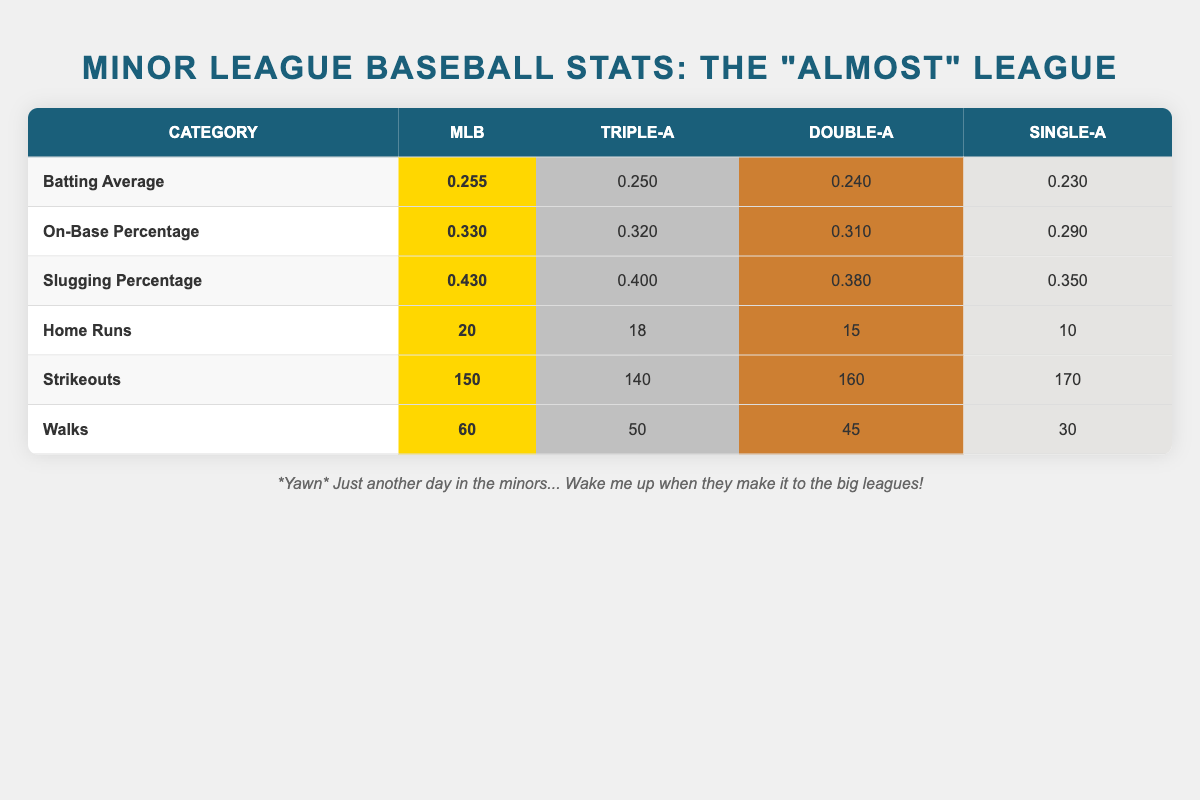What is the batting average for Triple-A players? In the table, under the "Batting Average" row for Triple-A, the value is listed as 0.250.
Answer: 0.250 How many home runs do Double-A players average? The table shows under the "Home Runs" row for Double-A that they average 15 home runs.
Answer: 15 Do Single-A players have a higher slugging percentage than Triple-A players? Looking at the "Slugging Percentage" row, Single-A has 0.350 while Triple-A has 0.400. Since 0.350 is less than 0.400, the answer is no.
Answer: No What is the difference in on-base percentage between MLB and Single-A players? The MLB on-base percentage is 0.330, while Single-A's is 0.290. The difference can be calculated by subtracting 0.290 from 0.330, resulting in 0.040.
Answer: 0.040 Which minor league category has the highest strikeout rate, and what is that rate? Checking the "Strikeouts" row, Single-A players have 170 strikeouts, making it the highest among the listed minor leagues.
Answer: Single-A, 170 